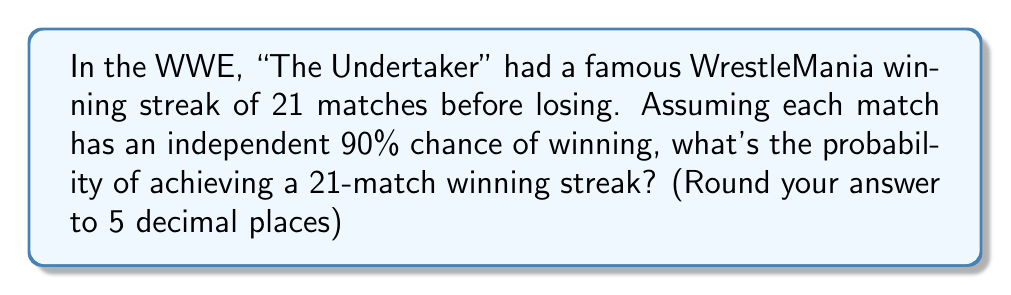Provide a solution to this math problem. Let's approach this step-by-step:

1) The probability of winning a single match is 90% or 0.9.

2) For a streak of 21 wins, we need to win 21 independent matches in a row.

3) The probability of independent events occurring together is the product of their individual probabilities.

4) Therefore, the probability of winning 21 matches in a row is:

   $$P(\text{21 wins}) = (0.9)^{21}$$

5) Let's calculate this:
   
   $$\begin{align}
   P(\text{21 wins}) &= (0.9)^{21} \\
   &= 0.9 \times 0.9 \times ... \times 0.9 \text{ (21 times)} \\
   &\approx 0.1094518691
   \end{align}$$

6) Rounding to 5 decimal places:

   $$P(\text{21 wins}) \approx 0.10945$$

This means there's about a 10.945% chance of achieving a 21-match winning streak under these conditions.
Answer: 0.10945 